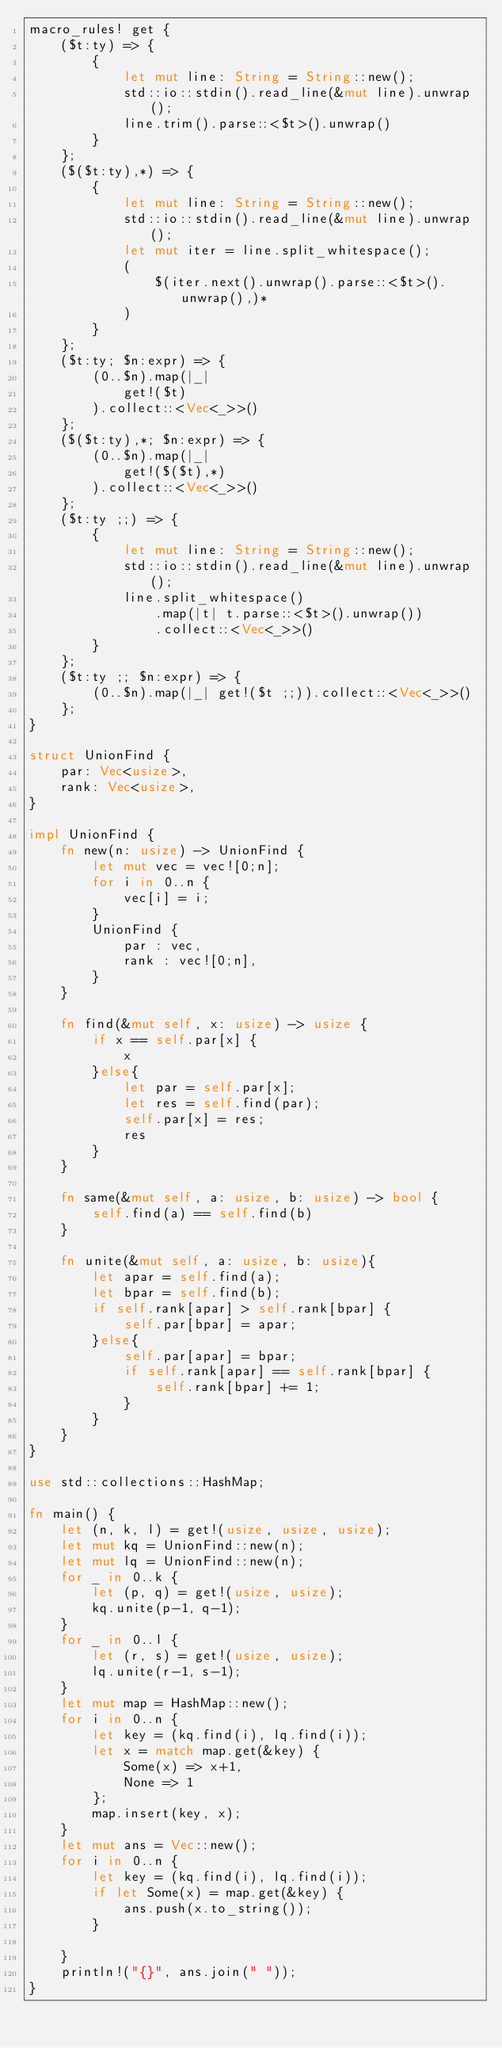<code> <loc_0><loc_0><loc_500><loc_500><_Rust_>macro_rules! get {
    ($t:ty) => {
        {
            let mut line: String = String::new();
            std::io::stdin().read_line(&mut line).unwrap();
            line.trim().parse::<$t>().unwrap()
        }
    };
    ($($t:ty),*) => {
        {
            let mut line: String = String::new();
            std::io::stdin().read_line(&mut line).unwrap();
            let mut iter = line.split_whitespace();
            (
                $(iter.next().unwrap().parse::<$t>().unwrap(),)*
            )
        }
    };
    ($t:ty; $n:expr) => {
        (0..$n).map(|_|
            get!($t)
        ).collect::<Vec<_>>()
    };
    ($($t:ty),*; $n:expr) => {
        (0..$n).map(|_|
            get!($($t),*)
        ).collect::<Vec<_>>()
    };
    ($t:ty ;;) => {
        {
            let mut line: String = String::new();
            std::io::stdin().read_line(&mut line).unwrap();
            line.split_whitespace()
                .map(|t| t.parse::<$t>().unwrap())
                .collect::<Vec<_>>()
        }
    };
    ($t:ty ;; $n:expr) => {
        (0..$n).map(|_| get!($t ;;)).collect::<Vec<_>>()
    };
}

struct UnionFind {
    par: Vec<usize>,
    rank: Vec<usize>,
}

impl UnionFind {
    fn new(n: usize) -> UnionFind {
        let mut vec = vec![0;n];
        for i in 0..n {
            vec[i] = i;
        }
        UnionFind {
            par : vec,
            rank : vec![0;n],
        }
    }

    fn find(&mut self, x: usize) -> usize {
        if x == self.par[x] {
            x
        }else{
            let par = self.par[x];
            let res = self.find(par);
            self.par[x] = res;
            res
        }
    }

    fn same(&mut self, a: usize, b: usize) -> bool {
        self.find(a) == self.find(b)
    }

    fn unite(&mut self, a: usize, b: usize){
        let apar = self.find(a);
        let bpar = self.find(b);
        if self.rank[apar] > self.rank[bpar] {
            self.par[bpar] = apar;
        }else{
            self.par[apar] = bpar;
            if self.rank[apar] == self.rank[bpar] {
                self.rank[bpar] += 1;
            }
        }
    }
}

use std::collections::HashMap;

fn main() {
    let (n, k, l) = get!(usize, usize, usize);
    let mut kq = UnionFind::new(n);
    let mut lq = UnionFind::new(n);
    for _ in 0..k {
        let (p, q) = get!(usize, usize);
        kq.unite(p-1, q-1);
    }
    for _ in 0..l {
        let (r, s) = get!(usize, usize);
        lq.unite(r-1, s-1);
    }
    let mut map = HashMap::new();
    for i in 0..n {
        let key = (kq.find(i), lq.find(i));
        let x = match map.get(&key) {
            Some(x) => x+1,
            None => 1
        };
        map.insert(key, x);
    }
    let mut ans = Vec::new();
    for i in 0..n {
        let key = (kq.find(i), lq.find(i));
        if let Some(x) = map.get(&key) {
            ans.push(x.to_string());
        }
        
    }
    println!("{}", ans.join(" "));
}</code> 